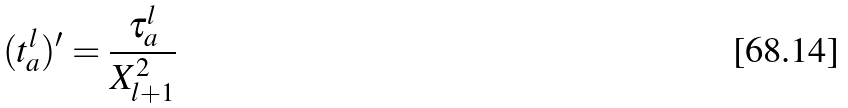Convert formula to latex. <formula><loc_0><loc_0><loc_500><loc_500>( t ^ { l } _ { a } ) ^ { \prime } = \frac { \tau _ { a } ^ { l } } { X ^ { 2 } _ { l + 1 } }</formula> 